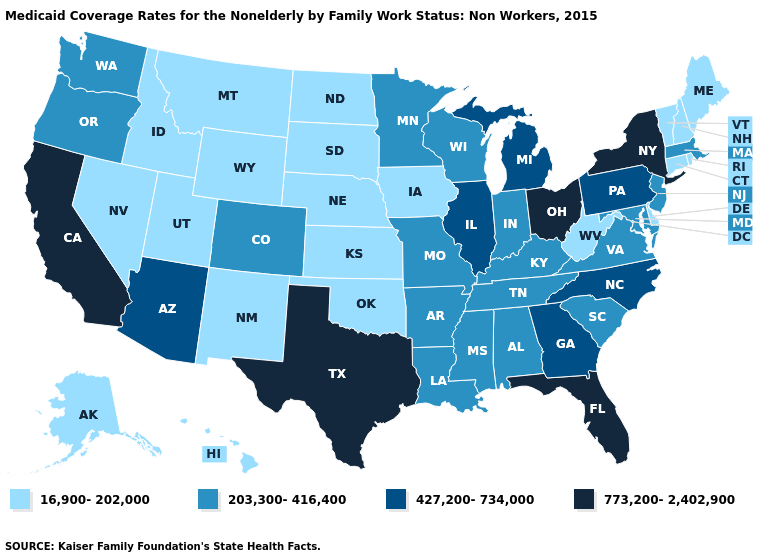What is the value of Minnesota?
Answer briefly. 203,300-416,400. Which states hav the highest value in the West?
Write a very short answer. California. What is the value of Vermont?
Keep it brief. 16,900-202,000. What is the value of Louisiana?
Short answer required. 203,300-416,400. Does New York have the lowest value in the USA?
Quick response, please. No. What is the lowest value in states that border Vermont?
Give a very brief answer. 16,900-202,000. What is the value of Virginia?
Keep it brief. 203,300-416,400. Name the states that have a value in the range 16,900-202,000?
Short answer required. Alaska, Connecticut, Delaware, Hawaii, Idaho, Iowa, Kansas, Maine, Montana, Nebraska, Nevada, New Hampshire, New Mexico, North Dakota, Oklahoma, Rhode Island, South Dakota, Utah, Vermont, West Virginia, Wyoming. What is the highest value in states that border Ohio?
Write a very short answer. 427,200-734,000. What is the highest value in states that border North Carolina?
Keep it brief. 427,200-734,000. What is the value of Vermont?
Be succinct. 16,900-202,000. What is the value of Indiana?
Quick response, please. 203,300-416,400. Which states hav the highest value in the South?
Be succinct. Florida, Texas. Does Massachusetts have the same value as Mississippi?
Be succinct. Yes. What is the value of North Carolina?
Be succinct. 427,200-734,000. 